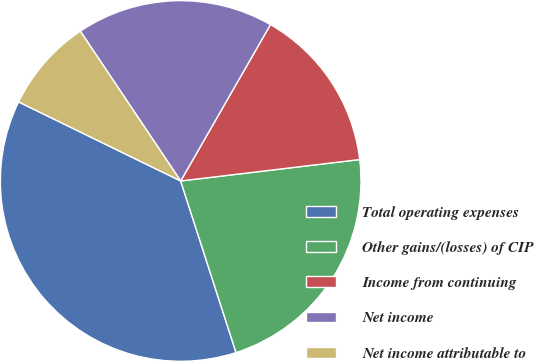<chart> <loc_0><loc_0><loc_500><loc_500><pie_chart><fcel>Total operating expenses<fcel>Other gains/(losses) of CIP<fcel>Income from continuing<fcel>Net income<fcel>Net income attributable to<nl><fcel>37.19%<fcel>21.93%<fcel>14.81%<fcel>17.69%<fcel>8.38%<nl></chart> 